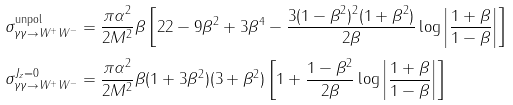Convert formula to latex. <formula><loc_0><loc_0><loc_500><loc_500>\sigma _ { \gamma \gamma \to W ^ { + } W ^ { - } } ^ { \text {unpol} } & = \frac { \pi \alpha ^ { 2 } } { 2 M ^ { 2 } } \beta \left [ 2 2 - 9 \beta ^ { 2 } + 3 \beta ^ { 4 } - \frac { 3 ( 1 - \beta ^ { 2 } ) ^ { 2 } ( 1 + \beta ^ { 2 } ) } { 2 \beta } \log \left | \frac { 1 + \beta } { 1 - \beta } \right | \right ] \\ \sigma _ { \gamma \gamma \to W ^ { + } W ^ { - } } ^ { J _ { z } = 0 } & = \frac { \pi \alpha ^ { 2 } } { 2 M ^ { 2 } } \beta ( 1 + 3 \beta ^ { 2 } ) ( 3 + \beta ^ { 2 } ) \left [ 1 + \frac { 1 - \beta ^ { 2 } } { 2 \beta } \log \left | \frac { 1 + \beta } { 1 - \beta } \right | \right ]</formula> 